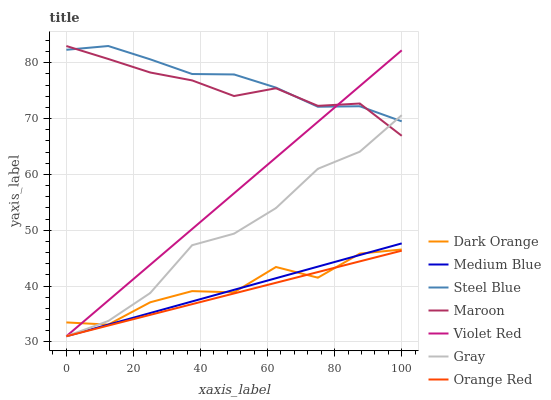Does Orange Red have the minimum area under the curve?
Answer yes or no. Yes. Does Steel Blue have the maximum area under the curve?
Answer yes or no. Yes. Does Violet Red have the minimum area under the curve?
Answer yes or no. No. Does Violet Red have the maximum area under the curve?
Answer yes or no. No. Is Violet Red the smoothest?
Answer yes or no. Yes. Is Dark Orange the roughest?
Answer yes or no. Yes. Is Gray the smoothest?
Answer yes or no. No. Is Gray the roughest?
Answer yes or no. No. Does Violet Red have the lowest value?
Answer yes or no. Yes. Does Steel Blue have the lowest value?
Answer yes or no. No. Does Maroon have the highest value?
Answer yes or no. Yes. Does Violet Red have the highest value?
Answer yes or no. No. Is Dark Orange less than Maroon?
Answer yes or no. Yes. Is Steel Blue greater than Dark Orange?
Answer yes or no. Yes. Does Gray intersect Dark Orange?
Answer yes or no. Yes. Is Gray less than Dark Orange?
Answer yes or no. No. Is Gray greater than Dark Orange?
Answer yes or no. No. Does Dark Orange intersect Maroon?
Answer yes or no. No. 